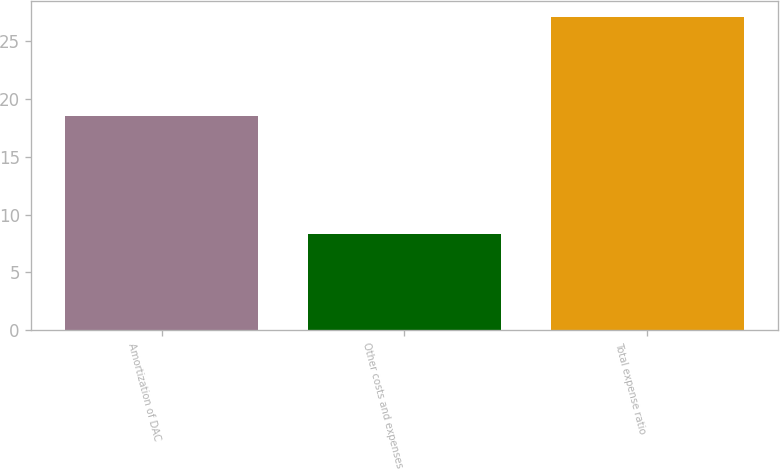Convert chart. <chart><loc_0><loc_0><loc_500><loc_500><bar_chart><fcel>Amortization of DAC<fcel>Other costs and expenses<fcel>Total expense ratio<nl><fcel>18.5<fcel>8.3<fcel>27.1<nl></chart> 